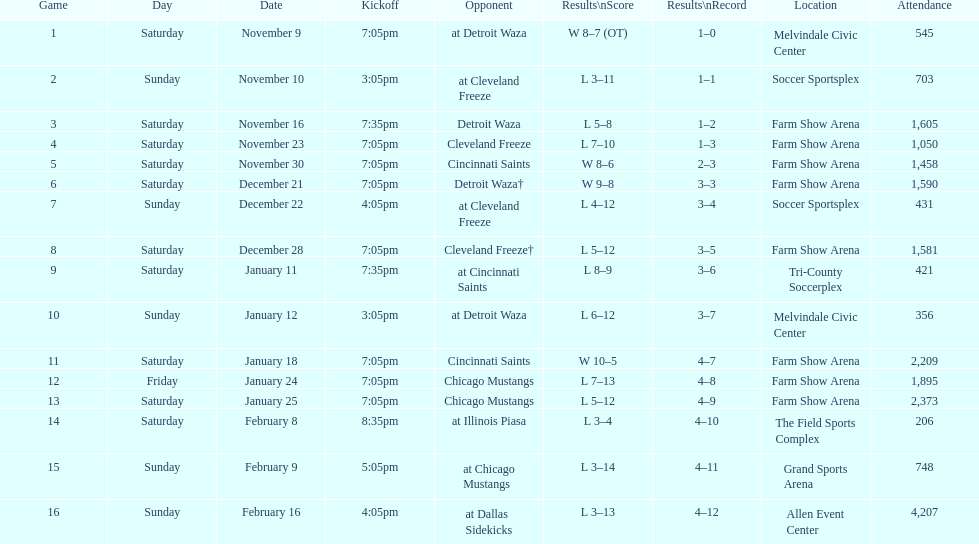How many games did the harrisburg heat win in which they scored eight or more goals? 4. 